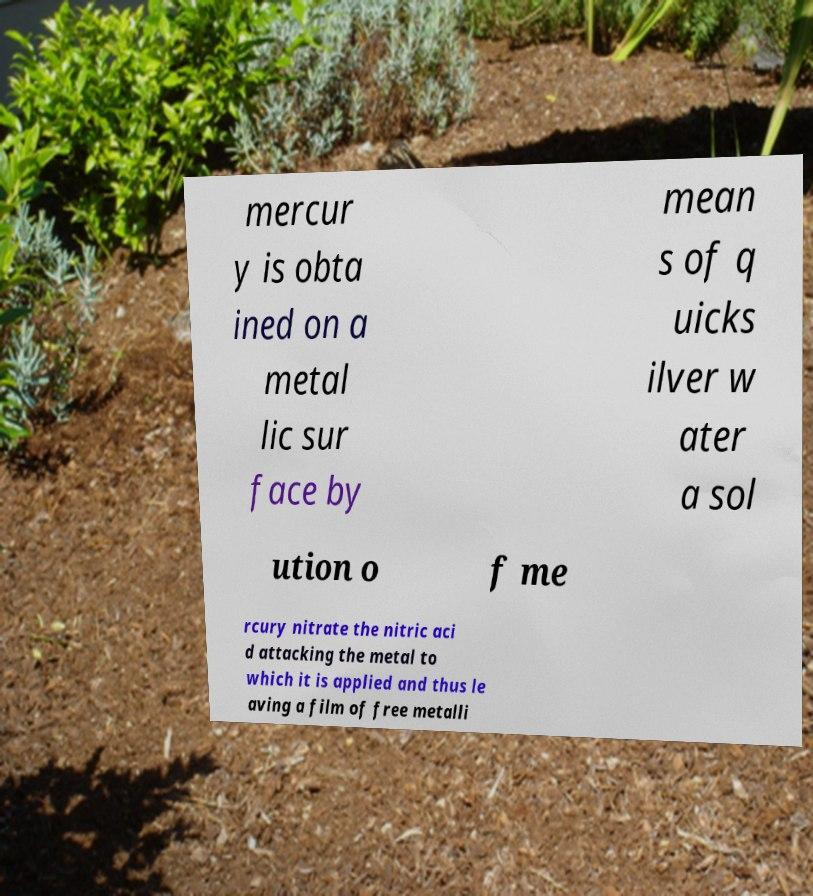Can you read and provide the text displayed in the image?This photo seems to have some interesting text. Can you extract and type it out for me? mercur y is obta ined on a metal lic sur face by mean s of q uicks ilver w ater a sol ution o f me rcury nitrate the nitric aci d attacking the metal to which it is applied and thus le aving a film of free metalli 